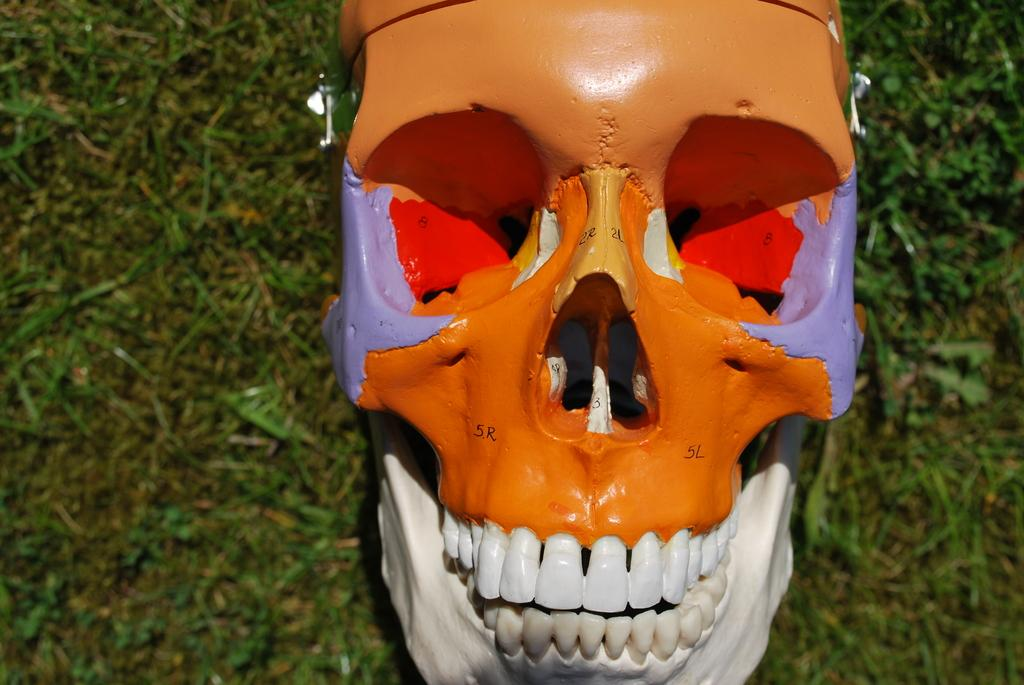What is on the ground in the image? There is a skull on the ground in the image. How is the skull decorated? The skull is painted with different colors. What type of bridge can be seen in the image? There is no bridge present in the image; it only features a painted skull on the ground. What shape is the rainstorm in the image? There is no rainstorm present in the image, so it is not possible to determine its shape. 